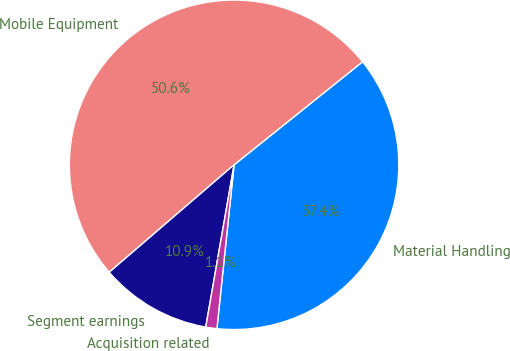Convert chart to OTSL. <chart><loc_0><loc_0><loc_500><loc_500><pie_chart><fcel>Material Handling<fcel>Mobile Equipment<fcel>Segment earnings<fcel>Acquisition related<nl><fcel>37.42%<fcel>50.55%<fcel>10.94%<fcel>1.09%<nl></chart> 